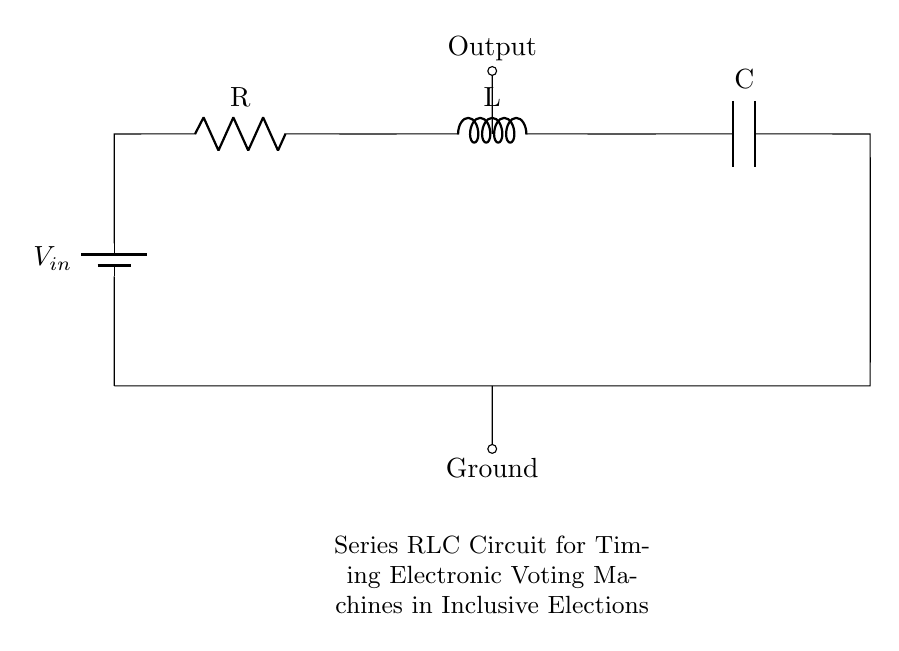What is the input voltage of the circuit? The input voltage, denoted as V_in, is represented next to the battery symbol in the diagram, indicating the source voltage for the circuit.
Answer: V_in What components are present in the series RLC circuit? The circuit diagram clearly shows three components: a resistor (R), an inductor (L), and a capacitor (C), all connected in series along with a voltage source.
Answer: Resistor, Inductor, Capacitor What is the total resistance in the circuit? The total resistance in a series circuit is simply the resistance of the resistor, denoted as R in the diagram.
Answer: R What is the function of the capacitor in this circuit? In a series RLC circuit, the capacitor stores and releases energy, thus affecting the timing characteristics of the circuit, which is vital for accurate timing in electronic voting machines.
Answer: Timing What type of circuit is shown in the diagram? The diagram illustrates a series RLC circuit, which means it consists of a resistor, inductor, and capacitor connected end-to-end in a single path.
Answer: Series RLC circuit How does the inductor affect the operation of the circuit? The inductor, denoted as L, introduces inductance into the circuit, opposing changes in current and affecting the timing behavior, especially during transient conditions when the system is powered on or off.
Answer: Timing behavior 